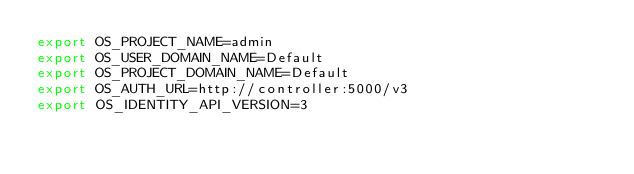Convert code to text. <code><loc_0><loc_0><loc_500><loc_500><_Bash_>export OS_PROJECT_NAME=admin
export OS_USER_DOMAIN_NAME=Default
export OS_PROJECT_DOMAIN_NAME=Default
export OS_AUTH_URL=http://controller:5000/v3
export OS_IDENTITY_API_VERSION=3
</code> 